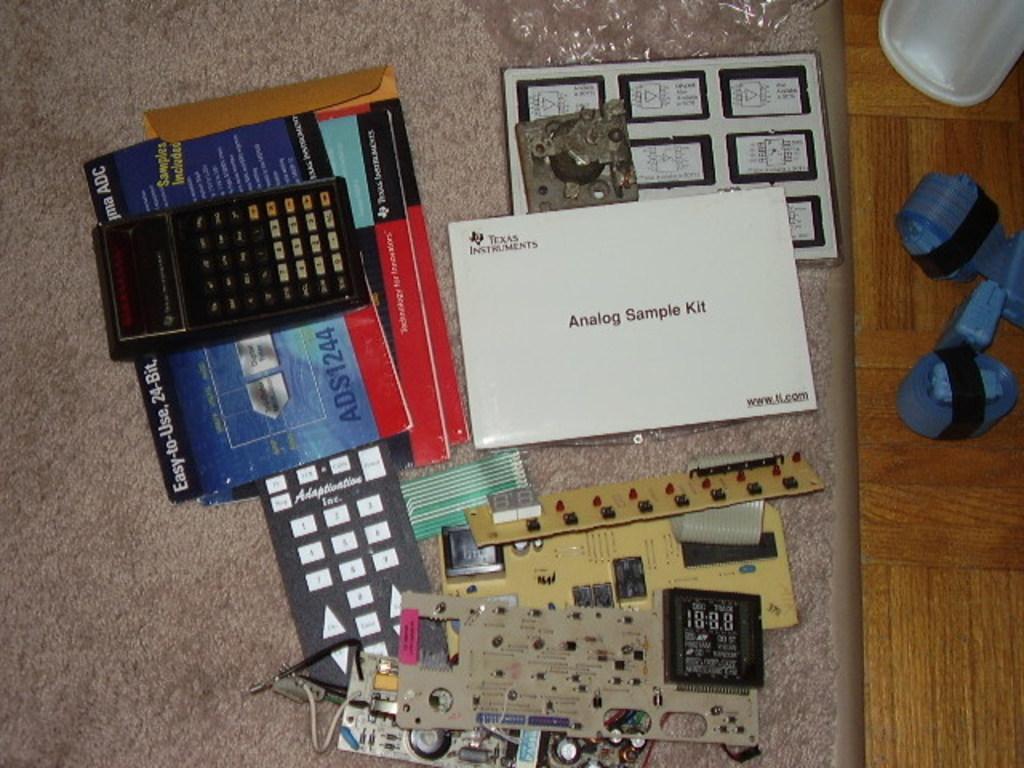What brand is advertised on the white paper?
Provide a short and direct response. Texas instruments. What kind of sample kit is the white catalog?
Provide a short and direct response. Analog. 